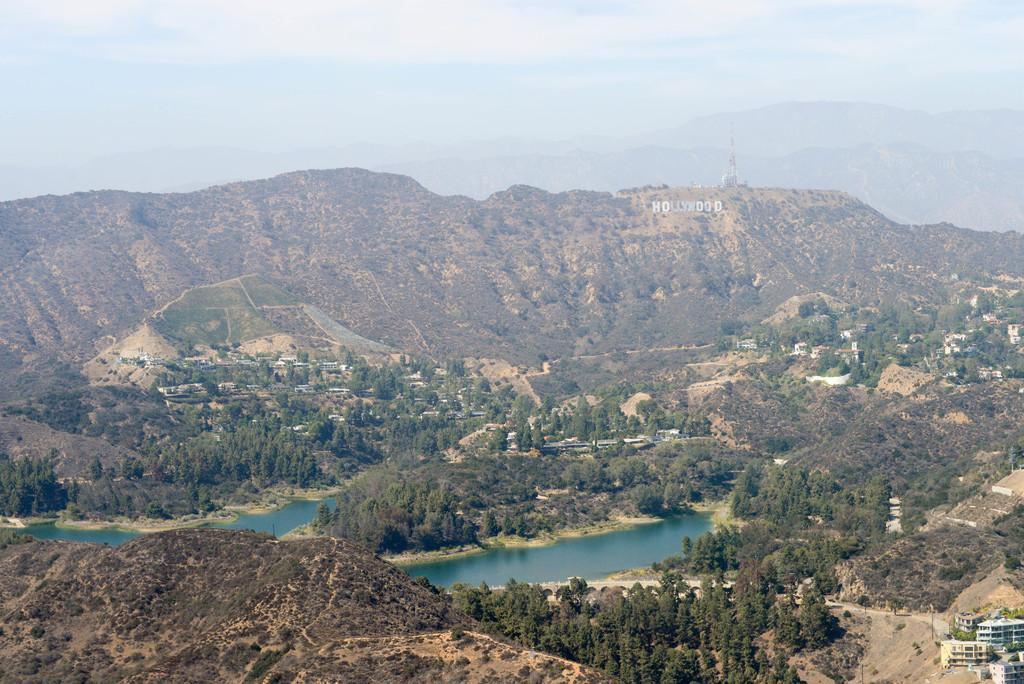Please provide a concise description of this image. In this picture I can see there are few mountains and they are covered with trees, there are few buildings and the sky is clear. 